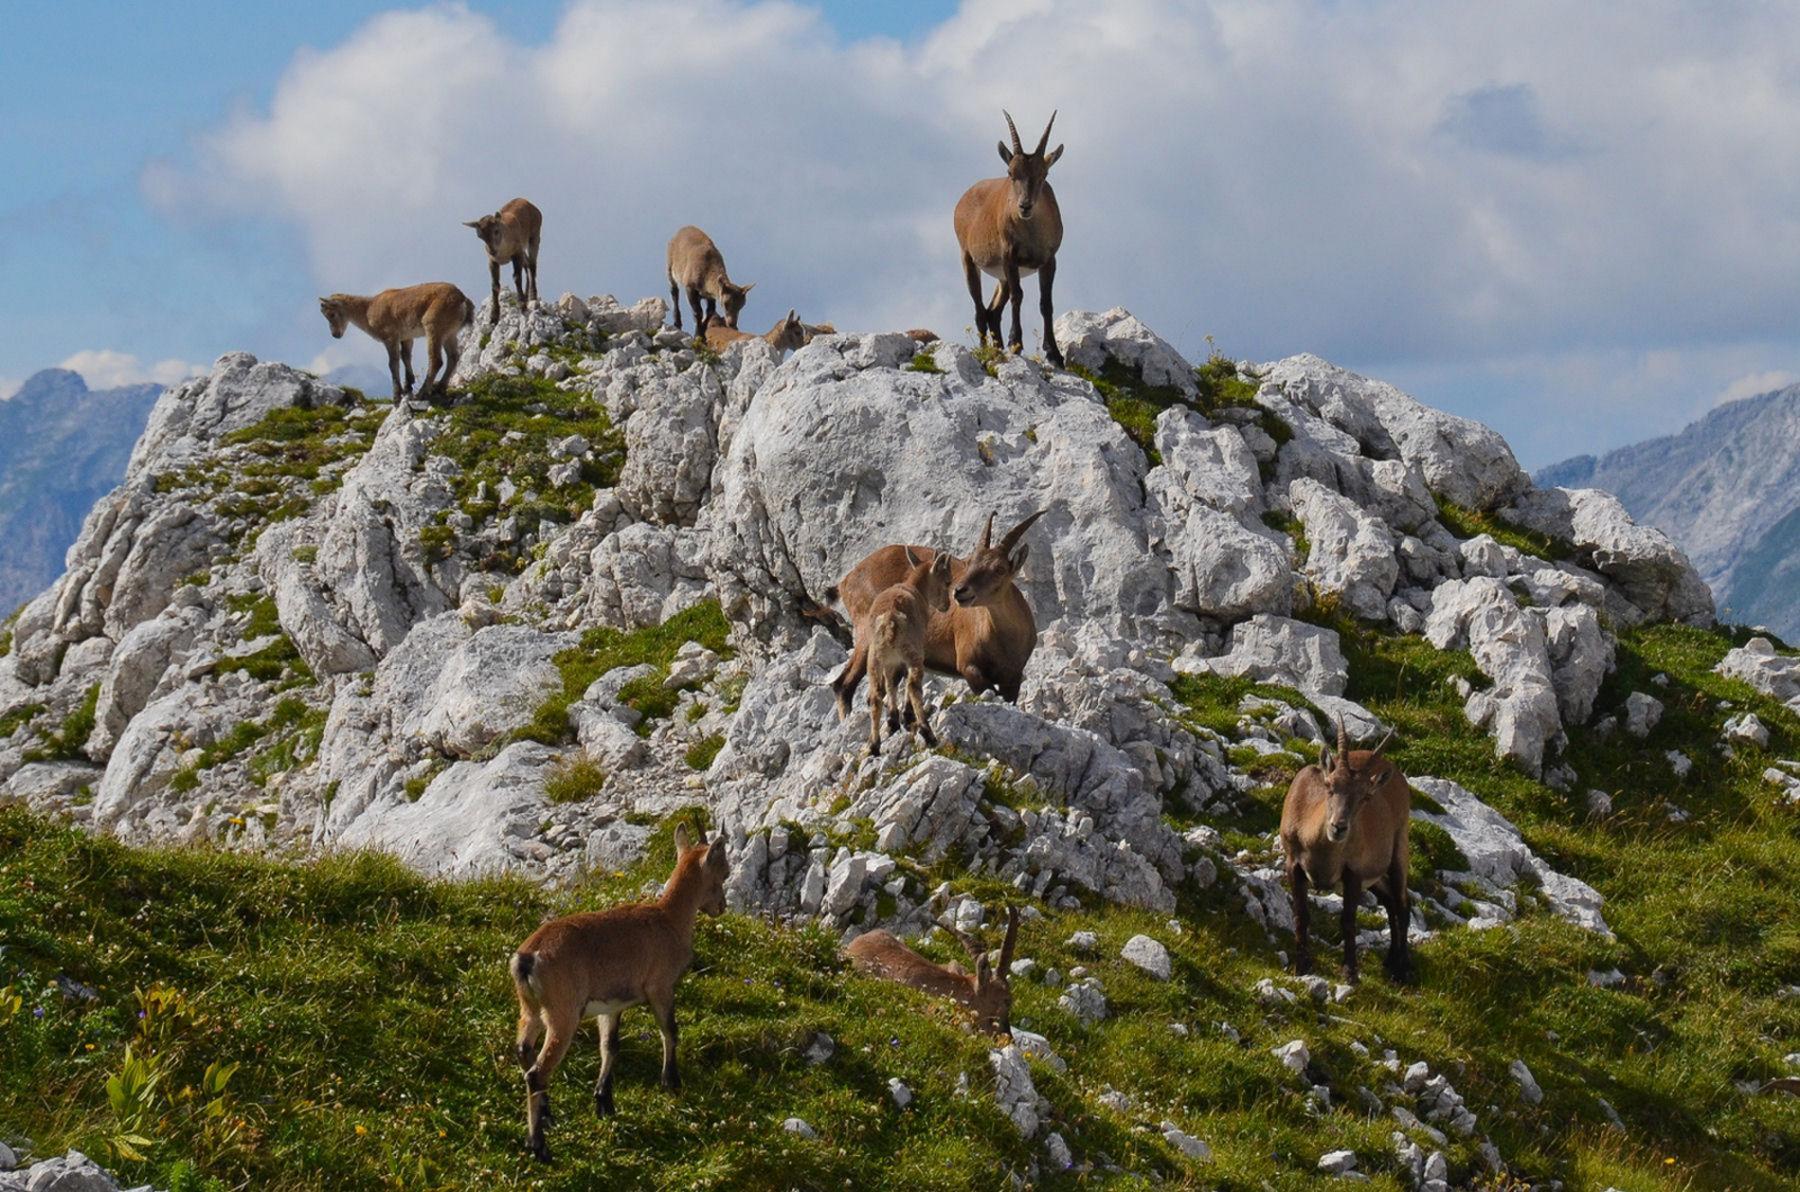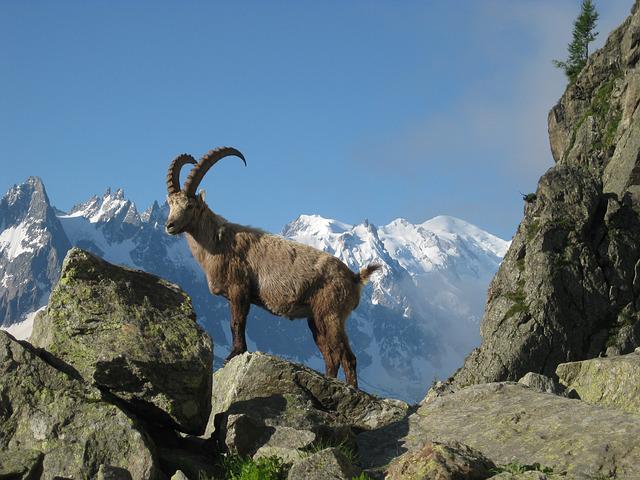The first image is the image on the left, the second image is the image on the right. Considering the images on both sides, is "There is only one antelope in one of the images" valid? Answer yes or no. Yes. The first image is the image on the left, the second image is the image on the right. Evaluate the accuracy of this statement regarding the images: "An image shows no more than two goats standing on a rock peak.". Is it true? Answer yes or no. Yes. 